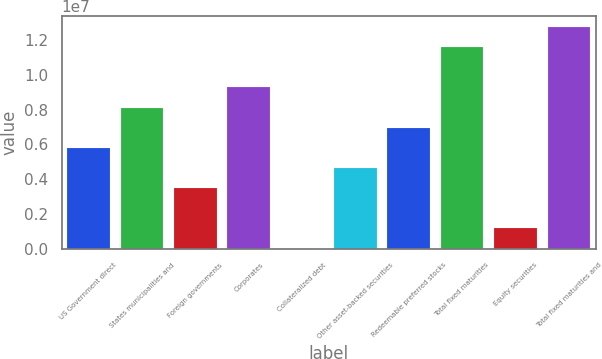Convert chart. <chart><loc_0><loc_0><loc_500><loc_500><bar_chart><fcel>US Government direct<fcel>States municipalities and<fcel>Foreign governments<fcel>Corporates<fcel>Collateralized debt<fcel>Other asset-backed securities<fcel>Redeemable preferred stocks<fcel>Total fixed maturities<fcel>Equity securities<fcel>Total fixed maturities and<nl><fcel>5.7969e+06<fcel>8.11567e+06<fcel>3.47814e+06<fcel>9.27505e+06<fcel>0.33<fcel>4.63752e+06<fcel>6.95628e+06<fcel>1.15938e+07<fcel>1.15938e+06<fcel>1.27532e+07<nl></chart> 